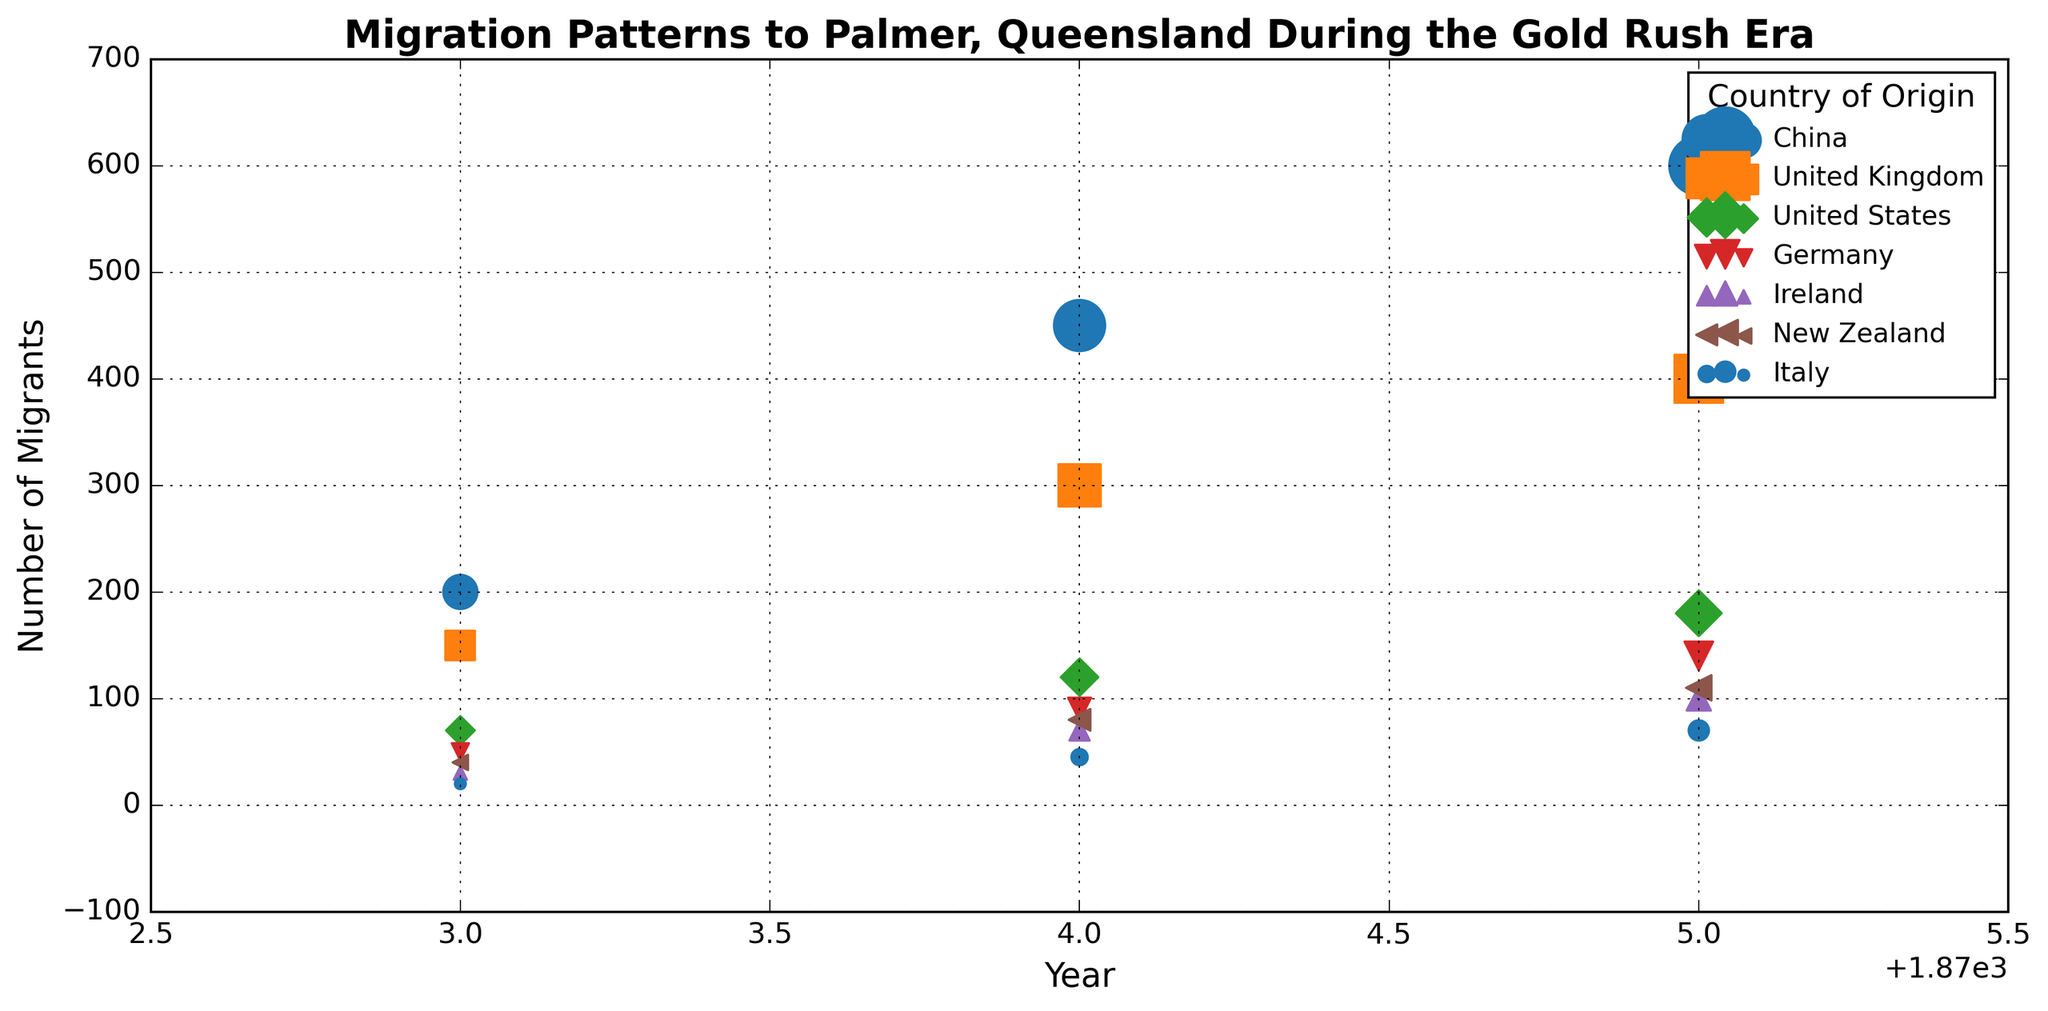What is the total number of Chinese migrants from 1873 to 1875? To find the total number of Chinese migrants, sum the values for each year: 200 (1873) + 450 (1874) + 600 (1875) = 1250.
Answer: 1250 Which year saw the highest number of migrants from the United Kingdom? By comparing the counts for each year, the counts are 150 (1873), 300 (1874), and 400 (1875). The highest count is 400 in the year 1875.
Answer: 1875 Did more migrants come from Ireland or Italy in 1874? Ireland had 70 migrants in 1874, while Italy had 45. Thus, more migrants came from Ireland.
Answer: Ireland Between 1873 and 1875, which country's migrant numbers increased the most? Calculate the increase for each country by subtracting the 1873 value from the 1875 value: China (600-200=400), United Kingdom (400-150=250), United States (180-70=110), Germany (140-50=90), Ireland (100-30=70), New Zealand (110-40=70), Italy (70-20=50). China had the largest increase of 400.
Answer: China What is the average number of migrants from Germany over the three years? Find the average by summing the annual counts and dividing by the number of years: (50 + 90 + 140) / 3 = 280 / 3 ≈ 93.33.
Answer: 93.33 Which country had the smallest total migrant count over the period? Sum the counts for each country: China (1250), United Kingdom (850), United States (370), Germany (280), Ireland (200), New Zealand (230), Italy (135). Italy had the smallest total count of 135.
Answer: Italy What was the increase in the number of United States migrants from 1874 to 1875? Subtract the 1874 count from the 1875 count: 180 - 120 = 60.
Answer: 60 In 1874, which country had the second highest number of migrants? The 1874 counts are China (450), United Kingdom (300), United States (120), Germany (90), Ireland (70), New Zealand (80), Italy (45). The second highest number is from the United Kingdom with 300 migrants.
Answer: United Kingdom 